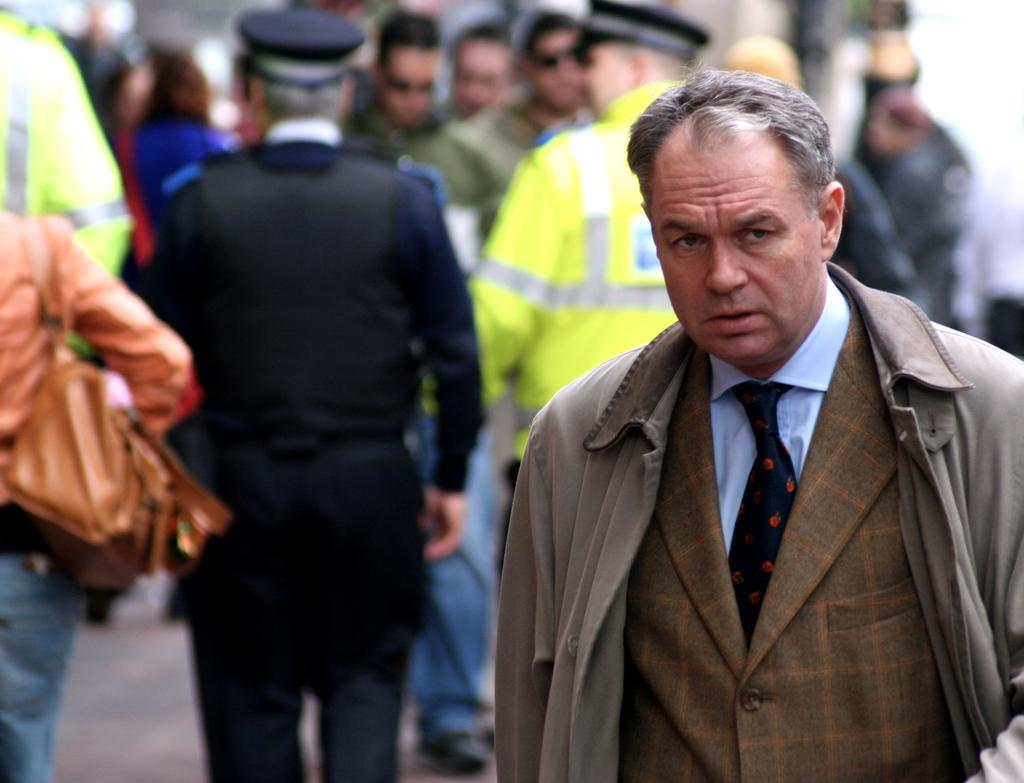What is the main subject of the image? The main subject of the image is a man standing. Can you describe the setting in the image? In the background of the image, there is a group of people standing. What type of drain is visible in the image? There is no drain present in the image. Can you tell me how many uncles are in the image? There is no mention of an uncle in the image. 